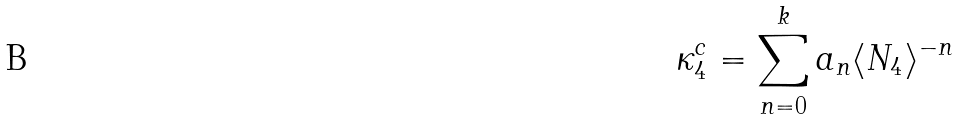Convert formula to latex. <formula><loc_0><loc_0><loc_500><loc_500>\kappa _ { 4 } ^ { c } = \sum _ { n = 0 } ^ { k } a _ { n } \langle N _ { 4 } \rangle ^ { - n }</formula> 